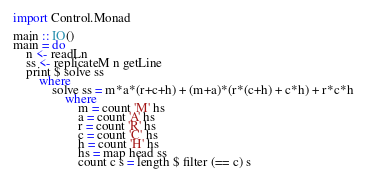Convert code to text. <code><loc_0><loc_0><loc_500><loc_500><_Haskell_>import Control.Monad

main :: IO()
main = do
    n <- readLn
    ss <- replicateM n getLine
    print $ solve ss
        where
            solve ss = m*a*(r+c+h) + (m+a)*(r*(c+h) + c*h) + r*c*h
                where
                    m = count 'M' hs
                    a = count 'A' hs
                    r = count 'R' hs
                    c = count 'C' hs
                    h = count 'H' hs
                    hs = map head ss
                    count c s = length $ filter (== c) s
</code> 